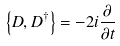Convert formula to latex. <formula><loc_0><loc_0><loc_500><loc_500>\left \{ D , D ^ { \dagger } \right \} = - 2 i { \frac { \partial } { \partial t } }</formula> 